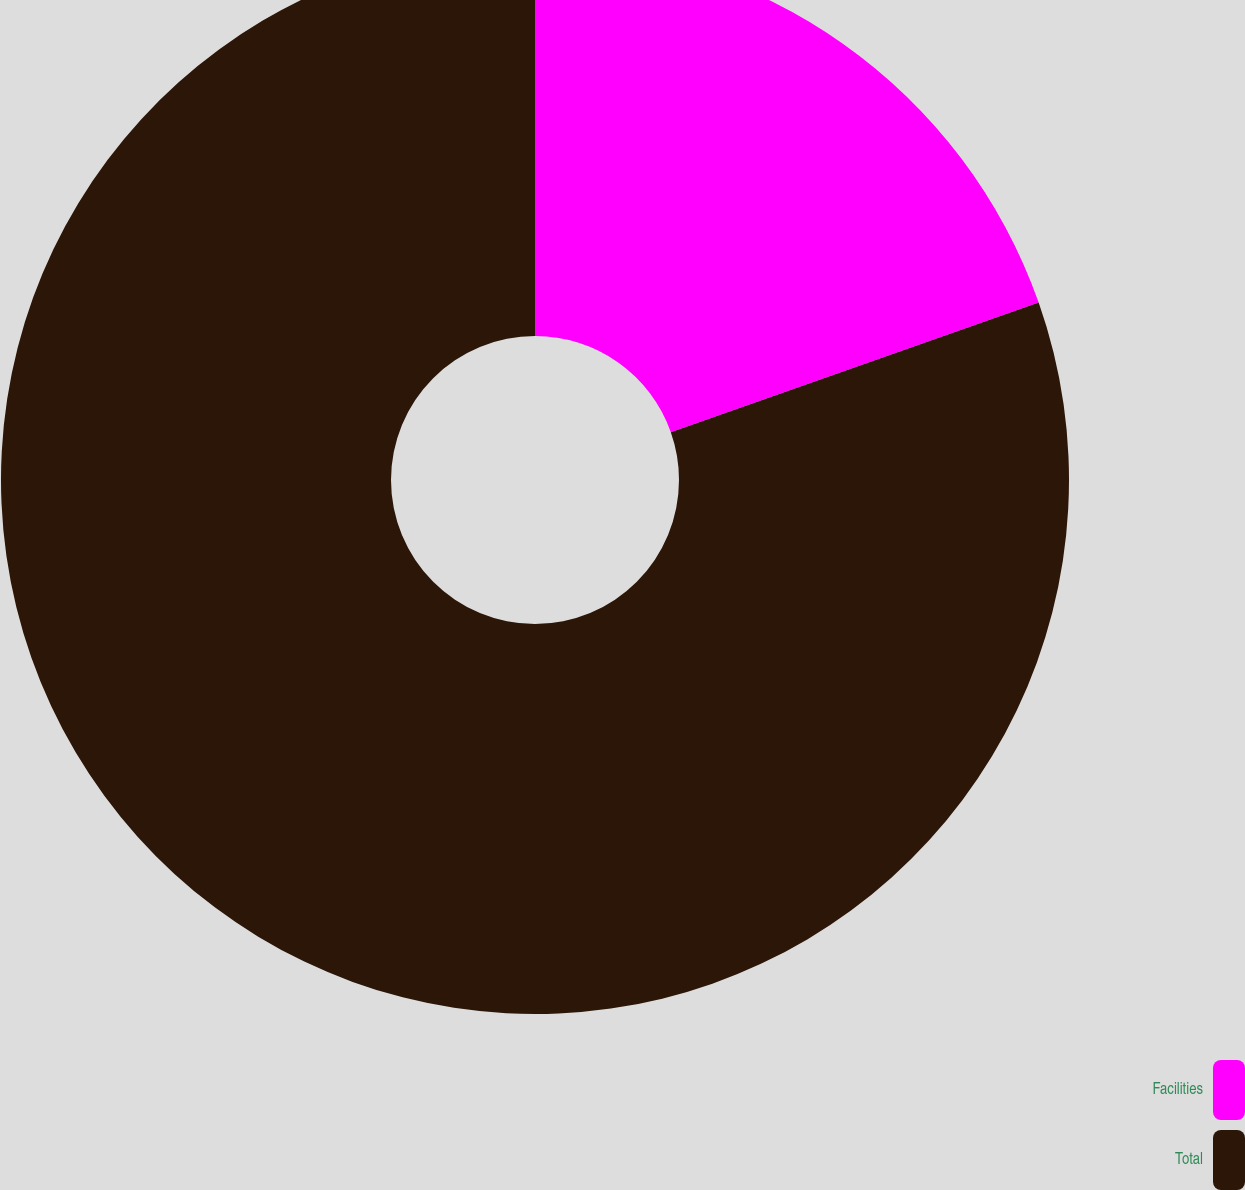Convert chart. <chart><loc_0><loc_0><loc_500><loc_500><pie_chart><fcel>Facilities<fcel>Total<nl><fcel>19.61%<fcel>80.39%<nl></chart> 